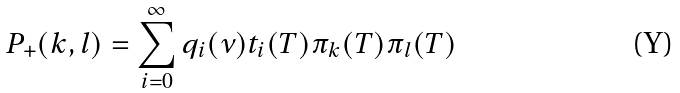Convert formula to latex. <formula><loc_0><loc_0><loc_500><loc_500>P _ { + } ( k , l ) = \sum _ { i = 0 } ^ { \infty } q _ { i } ( \nu ) t _ { i } ( T ) \pi _ { k } ( T ) \pi _ { l } ( T )</formula> 